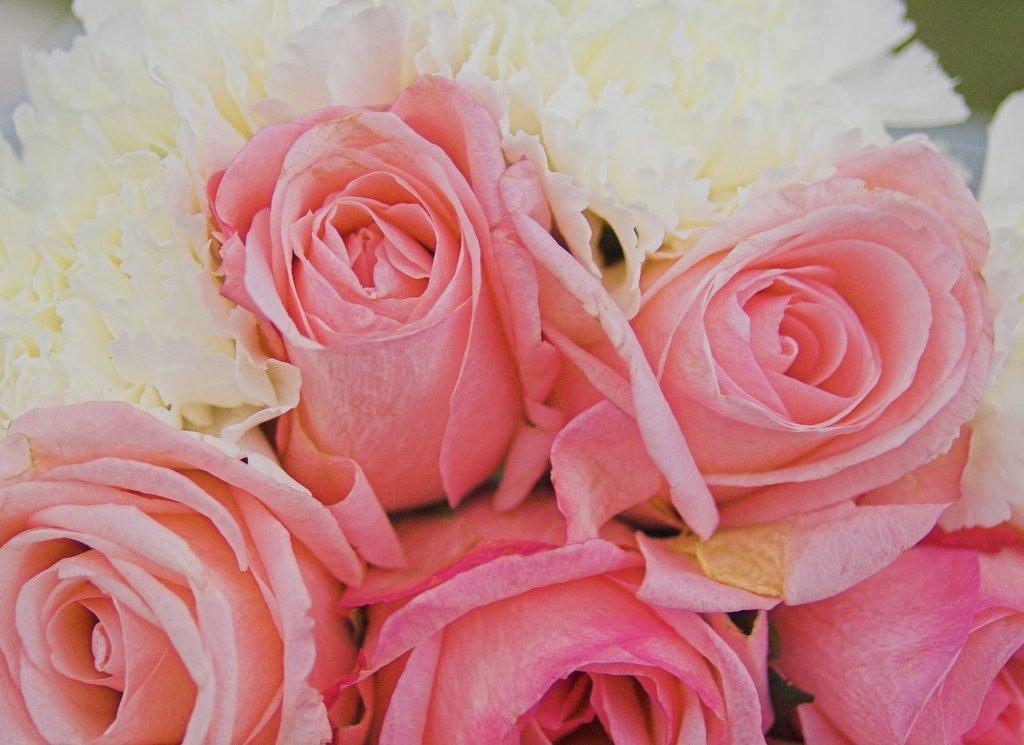Please provide a concise description of this image. In the picture there are different types of flowers present in a bunch. 